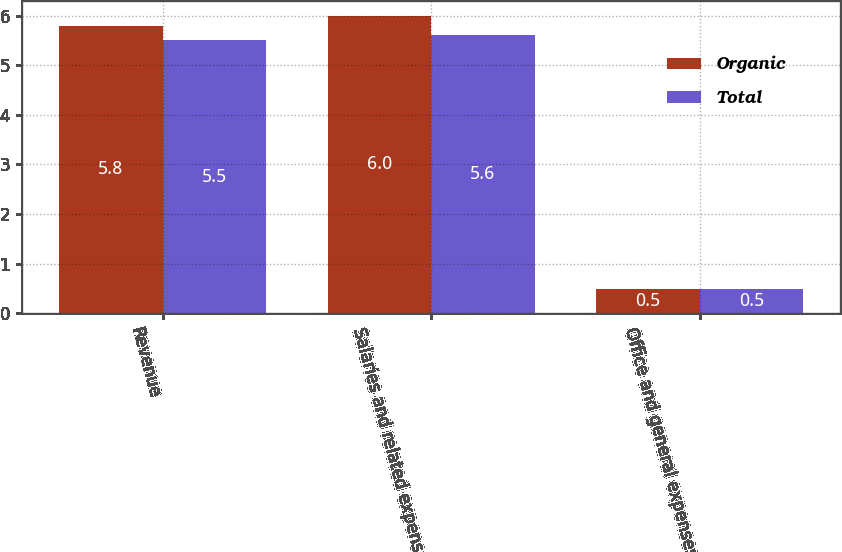Convert chart to OTSL. <chart><loc_0><loc_0><loc_500><loc_500><stacked_bar_chart><ecel><fcel>Revenue<fcel>Salaries and related expenses<fcel>Office and general expenses<nl><fcel>Organic<fcel>5.8<fcel>6<fcel>0.5<nl><fcel>Total<fcel>5.5<fcel>5.6<fcel>0.5<nl></chart> 